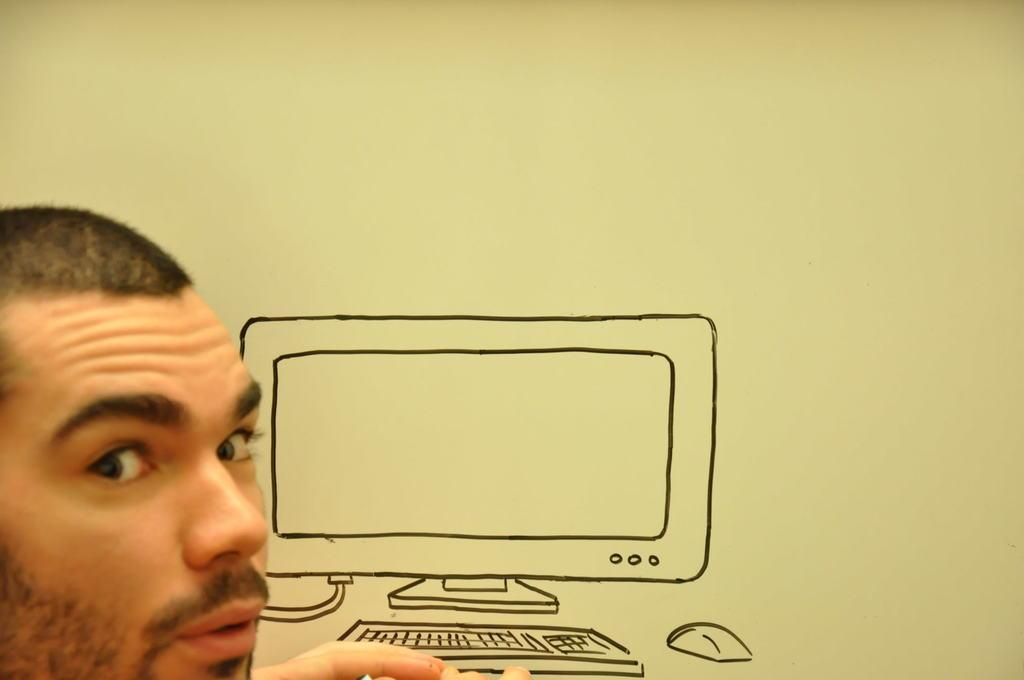What is the main subject of the image? There is a person in the image. Can you describe any additional details in the image? There is a drawing of a computer on the wall in the image. What type of music is the band playing in the image? There is no band present in the image, so it is not possible to determine what type of music they might be playing. 